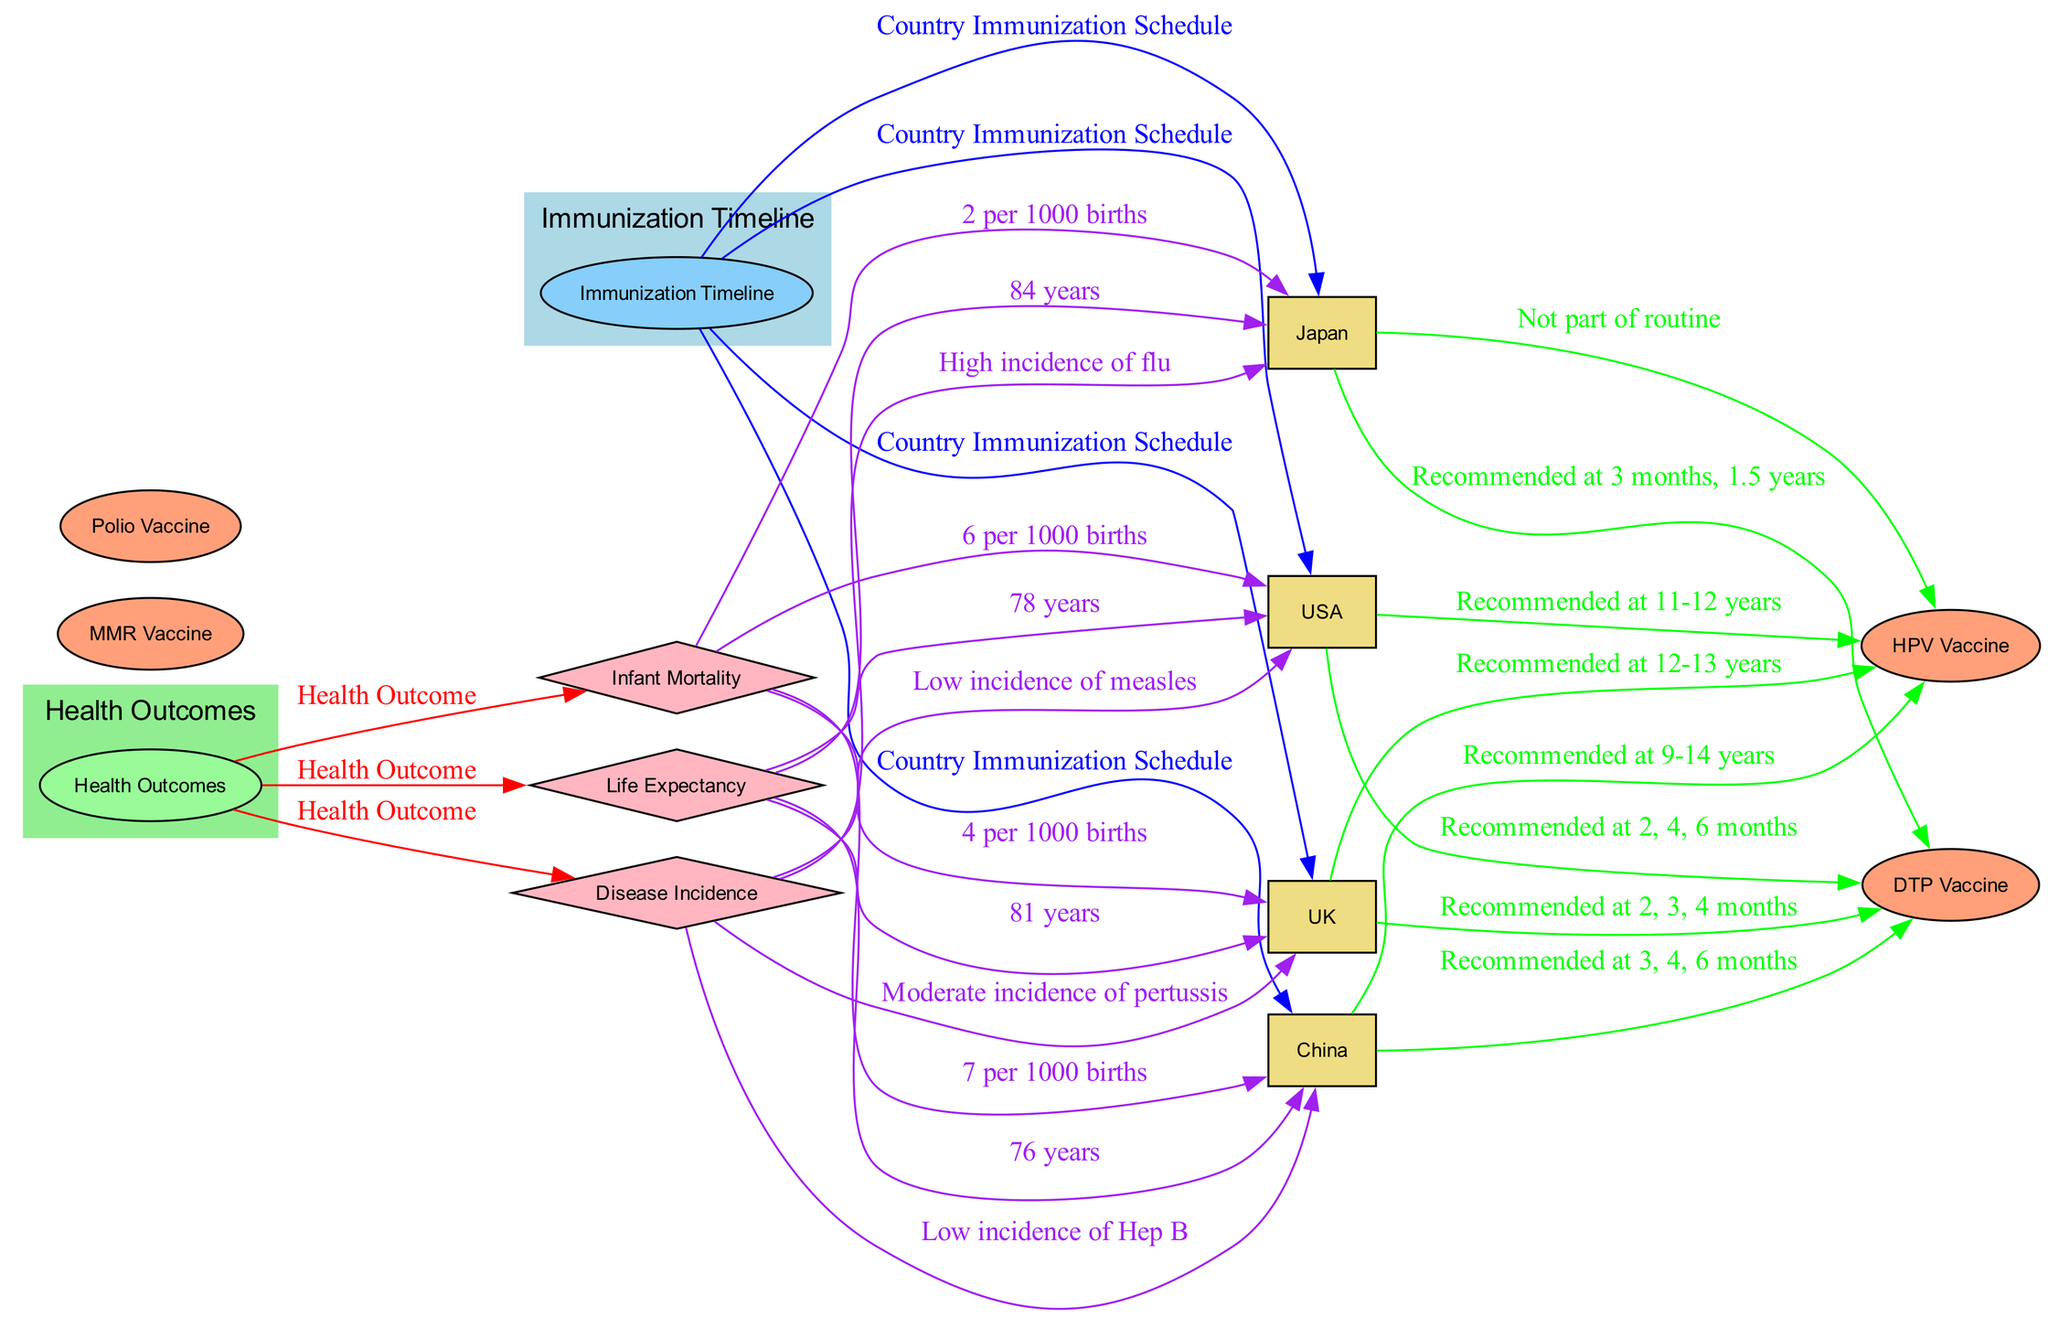What is the recommended age for the DTP vaccine in the USA? The diagram shows that the DTP vaccine is recommended at 2, 4, and 6 months for the USA. This is inferred by tracing the edge from the USA node to the DTP vaccine node, which specifies the timeline.
Answer: Recommended at 2, 4, 6 months How many countries are listed in the diagram? The diagram includes four countries: USA, UK, Japan, and China. Counting these nodes provides the answer.
Answer: Four What is the life expectancy in Japan? The diagram indicates that the life expectancy in Japan is 84 years. This is determined by tracing the edge from the Life Expectancy outcome to the Japan node.
Answer: 84 years Which country has the lowest infant mortality rate? The diagram indicates that Japan has the lowest infant mortality rate at 2 per 1000 births. Analyzing the statistics connected to the infant mortality outcome reveals this information.
Answer: Japan What type of relationship exists between health outcomes and countries? The diagram shows that the relationship is labeled as “Health Outcome” which connects the Health Outcomes node to multiple countries. This is identifiable through the edges between the two categories.
Answer: Health Outcome Which country has a moderate incidence of pertussis? The edge connected to the UK node describes the disease incidence, labeling it as having a moderate incidence of pertussis. Tracing the edge leads to this conclusion.
Answer: UK 